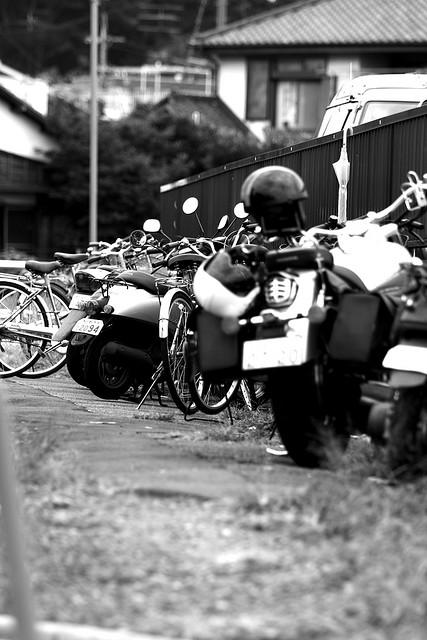What kind of transportation is shown? motorcycle 